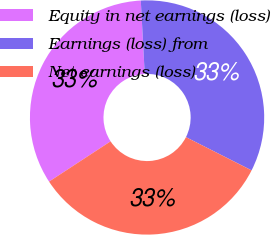<chart> <loc_0><loc_0><loc_500><loc_500><pie_chart><fcel>Equity in net earnings (loss)<fcel>Earnings (loss) from<fcel>Net earnings (loss)<nl><fcel>33.37%<fcel>33.31%<fcel>33.32%<nl></chart> 